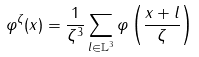Convert formula to latex. <formula><loc_0><loc_0><loc_500><loc_500>\varphi ^ { \zeta } ( x ) = \frac { 1 } { \zeta ^ { 3 } } \sum _ { l \in \mathbb { L } ^ { 3 } } \varphi \left ( \frac { x + l } { \zeta } \right )</formula> 